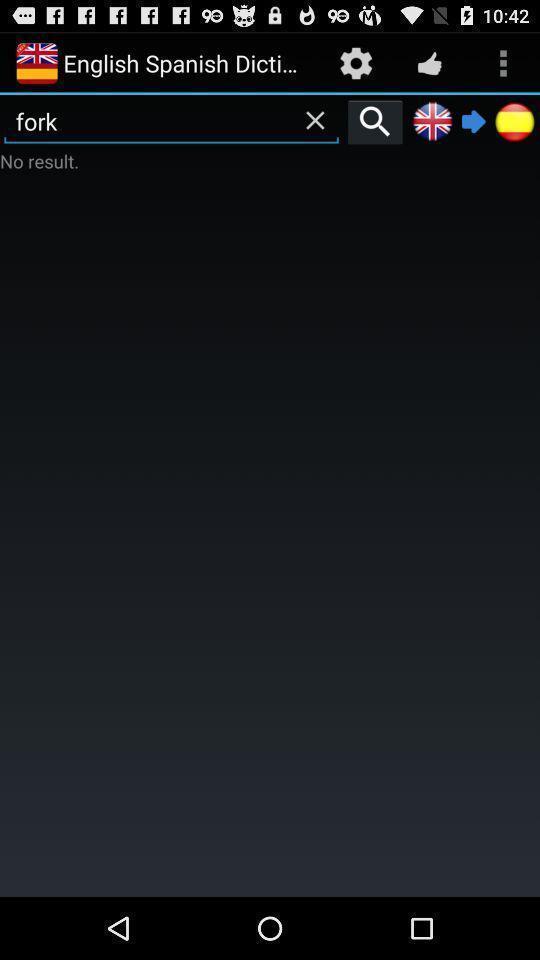Please provide a description for this image. Screen shows different options in dictionary app. 